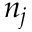Convert formula to latex. <formula><loc_0><loc_0><loc_500><loc_500>n _ { j }</formula> 